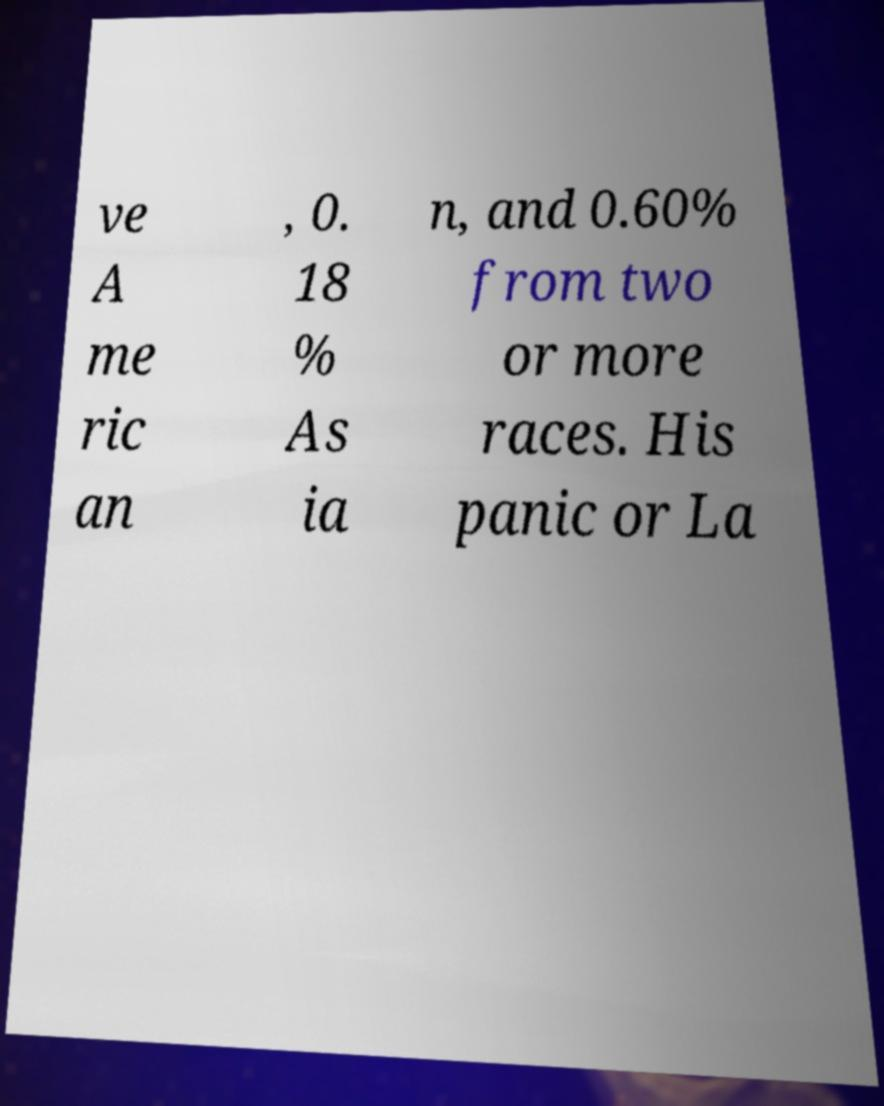Please identify and transcribe the text found in this image. ve A me ric an , 0. 18 % As ia n, and 0.60% from two or more races. His panic or La 